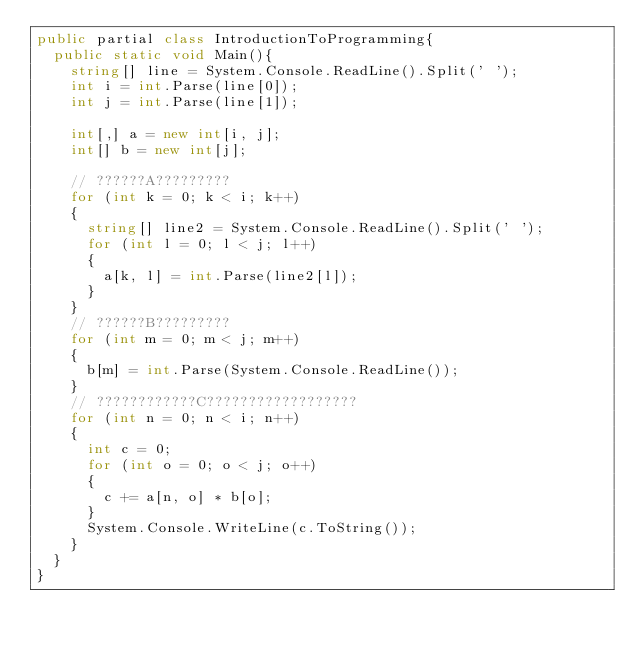Convert code to text. <code><loc_0><loc_0><loc_500><loc_500><_C#_>public partial class IntroductionToProgramming{
	public static void Main(){
		string[] line = System.Console.ReadLine().Split(' ');
		int i = int.Parse(line[0]);
		int j = int.Parse(line[1]);

		int[,] a = new int[i, j];
		int[] b = new int[j];

		// ??????A?????????
		for (int k = 0; k < i; k++)
		{
			string[] line2 = System.Console.ReadLine().Split(' ');
			for (int l = 0; l < j; l++)
			{
				a[k, l] = int.Parse(line2[l]);
			}
		}
		// ??????B?????????
		for (int m = 0; m < j; m++)
		{
			b[m] = int.Parse(System.Console.ReadLine());
		}
		// ????????????C??????????????????
		for (int n = 0; n < i; n++)
		{
			int c = 0;
			for (int o = 0; o < j; o++)
			{
				c += a[n, o] * b[o];
			}
			System.Console.WriteLine(c.ToString());
		}
	}
}</code> 